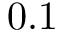Convert formula to latex. <formula><loc_0><loc_0><loc_500><loc_500>0 . 1</formula> 